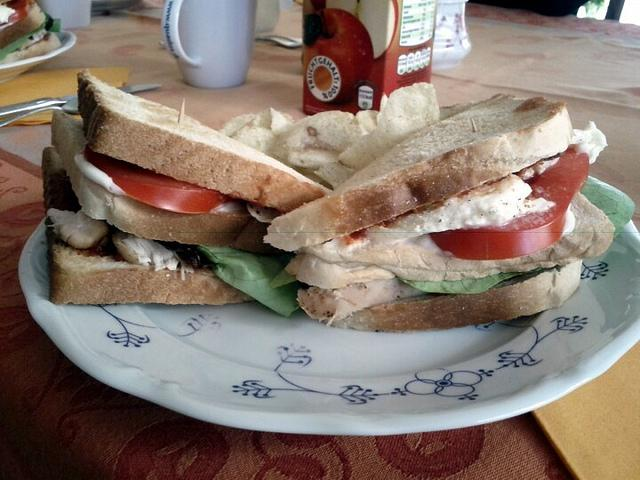What vegetable was used to make the side dish for this sandwich lunch? potato 